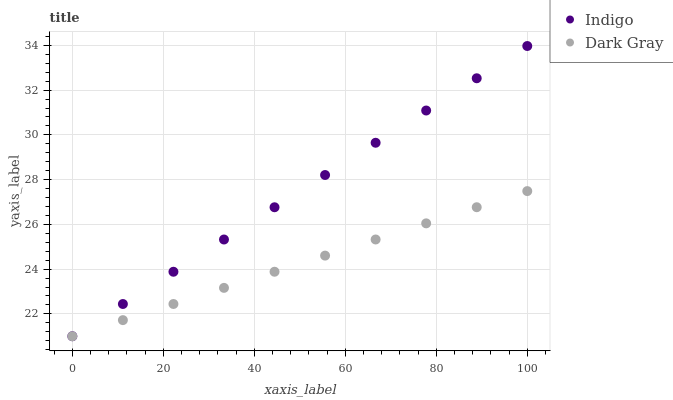Does Dark Gray have the minimum area under the curve?
Answer yes or no. Yes. Does Indigo have the maximum area under the curve?
Answer yes or no. Yes. Does Indigo have the minimum area under the curve?
Answer yes or no. No. Is Dark Gray the smoothest?
Answer yes or no. Yes. Is Indigo the roughest?
Answer yes or no. Yes. Is Indigo the smoothest?
Answer yes or no. No. Does Dark Gray have the lowest value?
Answer yes or no. Yes. Does Indigo have the highest value?
Answer yes or no. Yes. Does Indigo intersect Dark Gray?
Answer yes or no. Yes. Is Indigo less than Dark Gray?
Answer yes or no. No. Is Indigo greater than Dark Gray?
Answer yes or no. No. 